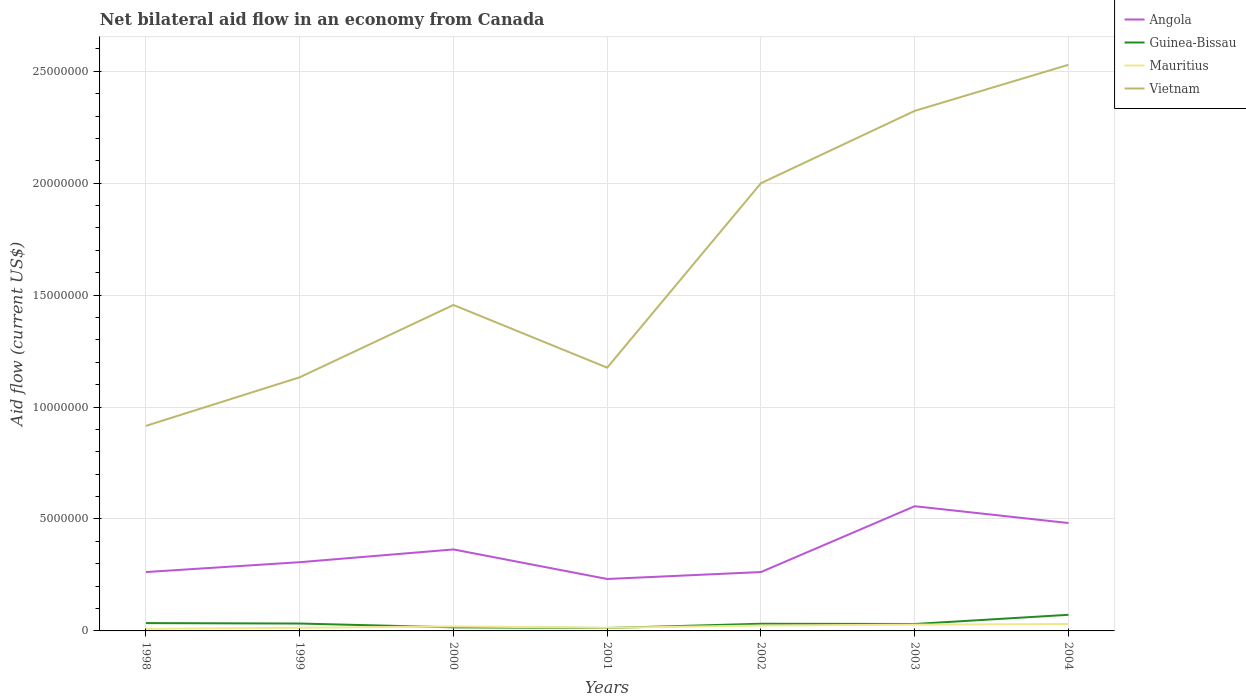Across all years, what is the maximum net bilateral aid flow in Angola?
Offer a terse response. 2.32e+06. In which year was the net bilateral aid flow in Vietnam maximum?
Offer a terse response. 1998. What is the total net bilateral aid flow in Mauritius in the graph?
Your response must be concise. 6.00e+04. What is the difference between the highest and the second highest net bilateral aid flow in Vietnam?
Offer a very short reply. 1.61e+07. Is the net bilateral aid flow in Mauritius strictly greater than the net bilateral aid flow in Vietnam over the years?
Keep it short and to the point. Yes. What is the difference between two consecutive major ticks on the Y-axis?
Your answer should be compact. 5.00e+06. Does the graph contain any zero values?
Keep it short and to the point. No. Where does the legend appear in the graph?
Keep it short and to the point. Top right. What is the title of the graph?
Offer a terse response. Net bilateral aid flow in an economy from Canada. Does "Latin America(developing only)" appear as one of the legend labels in the graph?
Provide a short and direct response. No. What is the label or title of the X-axis?
Offer a terse response. Years. What is the Aid flow (current US$) in Angola in 1998?
Provide a succinct answer. 2.63e+06. What is the Aid flow (current US$) of Guinea-Bissau in 1998?
Give a very brief answer. 3.50e+05. What is the Aid flow (current US$) of Vietnam in 1998?
Provide a succinct answer. 9.16e+06. What is the Aid flow (current US$) of Angola in 1999?
Offer a very short reply. 3.07e+06. What is the Aid flow (current US$) of Mauritius in 1999?
Ensure brevity in your answer.  1.40e+05. What is the Aid flow (current US$) in Vietnam in 1999?
Your answer should be compact. 1.13e+07. What is the Aid flow (current US$) in Angola in 2000?
Provide a succinct answer. 3.64e+06. What is the Aid flow (current US$) of Guinea-Bissau in 2000?
Give a very brief answer. 1.60e+05. What is the Aid flow (current US$) of Vietnam in 2000?
Offer a very short reply. 1.46e+07. What is the Aid flow (current US$) of Angola in 2001?
Give a very brief answer. 2.32e+06. What is the Aid flow (current US$) in Mauritius in 2001?
Your response must be concise. 1.40e+05. What is the Aid flow (current US$) of Vietnam in 2001?
Offer a very short reply. 1.18e+07. What is the Aid flow (current US$) of Angola in 2002?
Provide a succinct answer. 2.63e+06. What is the Aid flow (current US$) in Guinea-Bissau in 2002?
Your answer should be compact. 3.20e+05. What is the Aid flow (current US$) in Mauritius in 2002?
Your answer should be compact. 2.40e+05. What is the Aid flow (current US$) of Vietnam in 2002?
Keep it short and to the point. 2.00e+07. What is the Aid flow (current US$) in Angola in 2003?
Offer a terse response. 5.57e+06. What is the Aid flow (current US$) in Guinea-Bissau in 2003?
Make the answer very short. 3.10e+05. What is the Aid flow (current US$) in Mauritius in 2003?
Provide a succinct answer. 2.80e+05. What is the Aid flow (current US$) in Vietnam in 2003?
Provide a succinct answer. 2.32e+07. What is the Aid flow (current US$) in Angola in 2004?
Your answer should be compact. 4.82e+06. What is the Aid flow (current US$) of Guinea-Bissau in 2004?
Give a very brief answer. 7.20e+05. What is the Aid flow (current US$) in Vietnam in 2004?
Make the answer very short. 2.53e+07. Across all years, what is the maximum Aid flow (current US$) in Angola?
Ensure brevity in your answer.  5.57e+06. Across all years, what is the maximum Aid flow (current US$) in Guinea-Bissau?
Your response must be concise. 7.20e+05. Across all years, what is the maximum Aid flow (current US$) in Mauritius?
Offer a very short reply. 3.10e+05. Across all years, what is the maximum Aid flow (current US$) in Vietnam?
Your answer should be very brief. 2.53e+07. Across all years, what is the minimum Aid flow (current US$) of Angola?
Make the answer very short. 2.32e+06. Across all years, what is the minimum Aid flow (current US$) in Vietnam?
Make the answer very short. 9.16e+06. What is the total Aid flow (current US$) of Angola in the graph?
Ensure brevity in your answer.  2.47e+07. What is the total Aid flow (current US$) in Guinea-Bissau in the graph?
Provide a short and direct response. 2.32e+06. What is the total Aid flow (current US$) in Mauritius in the graph?
Give a very brief answer. 1.40e+06. What is the total Aid flow (current US$) in Vietnam in the graph?
Make the answer very short. 1.15e+08. What is the difference between the Aid flow (current US$) of Angola in 1998 and that in 1999?
Make the answer very short. -4.40e+05. What is the difference between the Aid flow (current US$) of Guinea-Bissau in 1998 and that in 1999?
Provide a short and direct response. 2.00e+04. What is the difference between the Aid flow (current US$) in Vietnam in 1998 and that in 1999?
Offer a very short reply. -2.17e+06. What is the difference between the Aid flow (current US$) in Angola in 1998 and that in 2000?
Give a very brief answer. -1.01e+06. What is the difference between the Aid flow (current US$) of Mauritius in 1998 and that in 2000?
Offer a very short reply. -1.10e+05. What is the difference between the Aid flow (current US$) in Vietnam in 1998 and that in 2000?
Offer a terse response. -5.40e+06. What is the difference between the Aid flow (current US$) of Guinea-Bissau in 1998 and that in 2001?
Keep it short and to the point. 2.20e+05. What is the difference between the Aid flow (current US$) in Mauritius in 1998 and that in 2001?
Give a very brief answer. -5.00e+04. What is the difference between the Aid flow (current US$) of Vietnam in 1998 and that in 2001?
Give a very brief answer. -2.60e+06. What is the difference between the Aid flow (current US$) of Guinea-Bissau in 1998 and that in 2002?
Your answer should be compact. 3.00e+04. What is the difference between the Aid flow (current US$) of Mauritius in 1998 and that in 2002?
Provide a succinct answer. -1.50e+05. What is the difference between the Aid flow (current US$) of Vietnam in 1998 and that in 2002?
Provide a succinct answer. -1.08e+07. What is the difference between the Aid flow (current US$) of Angola in 1998 and that in 2003?
Your answer should be compact. -2.94e+06. What is the difference between the Aid flow (current US$) in Mauritius in 1998 and that in 2003?
Give a very brief answer. -1.90e+05. What is the difference between the Aid flow (current US$) in Vietnam in 1998 and that in 2003?
Give a very brief answer. -1.41e+07. What is the difference between the Aid flow (current US$) of Angola in 1998 and that in 2004?
Give a very brief answer. -2.19e+06. What is the difference between the Aid flow (current US$) of Guinea-Bissau in 1998 and that in 2004?
Make the answer very short. -3.70e+05. What is the difference between the Aid flow (current US$) in Mauritius in 1998 and that in 2004?
Your response must be concise. -2.20e+05. What is the difference between the Aid flow (current US$) in Vietnam in 1998 and that in 2004?
Provide a short and direct response. -1.61e+07. What is the difference between the Aid flow (current US$) in Angola in 1999 and that in 2000?
Keep it short and to the point. -5.70e+05. What is the difference between the Aid flow (current US$) in Vietnam in 1999 and that in 2000?
Provide a short and direct response. -3.23e+06. What is the difference between the Aid flow (current US$) in Angola in 1999 and that in 2001?
Make the answer very short. 7.50e+05. What is the difference between the Aid flow (current US$) in Guinea-Bissau in 1999 and that in 2001?
Provide a succinct answer. 2.00e+05. What is the difference between the Aid flow (current US$) of Vietnam in 1999 and that in 2001?
Ensure brevity in your answer.  -4.30e+05. What is the difference between the Aid flow (current US$) in Guinea-Bissau in 1999 and that in 2002?
Make the answer very short. 10000. What is the difference between the Aid flow (current US$) of Vietnam in 1999 and that in 2002?
Your answer should be compact. -8.67e+06. What is the difference between the Aid flow (current US$) in Angola in 1999 and that in 2003?
Provide a short and direct response. -2.50e+06. What is the difference between the Aid flow (current US$) in Vietnam in 1999 and that in 2003?
Provide a short and direct response. -1.19e+07. What is the difference between the Aid flow (current US$) in Angola in 1999 and that in 2004?
Provide a succinct answer. -1.75e+06. What is the difference between the Aid flow (current US$) of Guinea-Bissau in 1999 and that in 2004?
Provide a short and direct response. -3.90e+05. What is the difference between the Aid flow (current US$) in Vietnam in 1999 and that in 2004?
Offer a terse response. -1.40e+07. What is the difference between the Aid flow (current US$) of Angola in 2000 and that in 2001?
Give a very brief answer. 1.32e+06. What is the difference between the Aid flow (current US$) in Mauritius in 2000 and that in 2001?
Offer a terse response. 6.00e+04. What is the difference between the Aid flow (current US$) of Vietnam in 2000 and that in 2001?
Keep it short and to the point. 2.80e+06. What is the difference between the Aid flow (current US$) in Angola in 2000 and that in 2002?
Make the answer very short. 1.01e+06. What is the difference between the Aid flow (current US$) of Guinea-Bissau in 2000 and that in 2002?
Ensure brevity in your answer.  -1.60e+05. What is the difference between the Aid flow (current US$) in Vietnam in 2000 and that in 2002?
Provide a short and direct response. -5.44e+06. What is the difference between the Aid flow (current US$) in Angola in 2000 and that in 2003?
Offer a very short reply. -1.93e+06. What is the difference between the Aid flow (current US$) in Guinea-Bissau in 2000 and that in 2003?
Your response must be concise. -1.50e+05. What is the difference between the Aid flow (current US$) in Mauritius in 2000 and that in 2003?
Offer a terse response. -8.00e+04. What is the difference between the Aid flow (current US$) of Vietnam in 2000 and that in 2003?
Ensure brevity in your answer.  -8.67e+06. What is the difference between the Aid flow (current US$) of Angola in 2000 and that in 2004?
Make the answer very short. -1.18e+06. What is the difference between the Aid flow (current US$) of Guinea-Bissau in 2000 and that in 2004?
Ensure brevity in your answer.  -5.60e+05. What is the difference between the Aid flow (current US$) of Mauritius in 2000 and that in 2004?
Offer a terse response. -1.10e+05. What is the difference between the Aid flow (current US$) of Vietnam in 2000 and that in 2004?
Your answer should be very brief. -1.07e+07. What is the difference between the Aid flow (current US$) in Angola in 2001 and that in 2002?
Provide a short and direct response. -3.10e+05. What is the difference between the Aid flow (current US$) of Guinea-Bissau in 2001 and that in 2002?
Provide a succinct answer. -1.90e+05. What is the difference between the Aid flow (current US$) in Vietnam in 2001 and that in 2002?
Ensure brevity in your answer.  -8.24e+06. What is the difference between the Aid flow (current US$) of Angola in 2001 and that in 2003?
Ensure brevity in your answer.  -3.25e+06. What is the difference between the Aid flow (current US$) of Vietnam in 2001 and that in 2003?
Give a very brief answer. -1.15e+07. What is the difference between the Aid flow (current US$) in Angola in 2001 and that in 2004?
Keep it short and to the point. -2.50e+06. What is the difference between the Aid flow (current US$) in Guinea-Bissau in 2001 and that in 2004?
Offer a terse response. -5.90e+05. What is the difference between the Aid flow (current US$) in Mauritius in 2001 and that in 2004?
Offer a terse response. -1.70e+05. What is the difference between the Aid flow (current US$) of Vietnam in 2001 and that in 2004?
Give a very brief answer. -1.35e+07. What is the difference between the Aid flow (current US$) in Angola in 2002 and that in 2003?
Provide a short and direct response. -2.94e+06. What is the difference between the Aid flow (current US$) in Vietnam in 2002 and that in 2003?
Your response must be concise. -3.23e+06. What is the difference between the Aid flow (current US$) in Angola in 2002 and that in 2004?
Make the answer very short. -2.19e+06. What is the difference between the Aid flow (current US$) of Guinea-Bissau in 2002 and that in 2004?
Provide a succinct answer. -4.00e+05. What is the difference between the Aid flow (current US$) of Mauritius in 2002 and that in 2004?
Offer a terse response. -7.00e+04. What is the difference between the Aid flow (current US$) in Vietnam in 2002 and that in 2004?
Provide a succinct answer. -5.29e+06. What is the difference between the Aid flow (current US$) of Angola in 2003 and that in 2004?
Offer a very short reply. 7.50e+05. What is the difference between the Aid flow (current US$) in Guinea-Bissau in 2003 and that in 2004?
Ensure brevity in your answer.  -4.10e+05. What is the difference between the Aid flow (current US$) of Mauritius in 2003 and that in 2004?
Make the answer very short. -3.00e+04. What is the difference between the Aid flow (current US$) in Vietnam in 2003 and that in 2004?
Your answer should be compact. -2.06e+06. What is the difference between the Aid flow (current US$) of Angola in 1998 and the Aid flow (current US$) of Guinea-Bissau in 1999?
Offer a terse response. 2.30e+06. What is the difference between the Aid flow (current US$) in Angola in 1998 and the Aid flow (current US$) in Mauritius in 1999?
Offer a very short reply. 2.49e+06. What is the difference between the Aid flow (current US$) of Angola in 1998 and the Aid flow (current US$) of Vietnam in 1999?
Your answer should be compact. -8.70e+06. What is the difference between the Aid flow (current US$) of Guinea-Bissau in 1998 and the Aid flow (current US$) of Vietnam in 1999?
Make the answer very short. -1.10e+07. What is the difference between the Aid flow (current US$) of Mauritius in 1998 and the Aid flow (current US$) of Vietnam in 1999?
Offer a very short reply. -1.12e+07. What is the difference between the Aid flow (current US$) in Angola in 1998 and the Aid flow (current US$) in Guinea-Bissau in 2000?
Offer a terse response. 2.47e+06. What is the difference between the Aid flow (current US$) in Angola in 1998 and the Aid flow (current US$) in Mauritius in 2000?
Your response must be concise. 2.43e+06. What is the difference between the Aid flow (current US$) of Angola in 1998 and the Aid flow (current US$) of Vietnam in 2000?
Offer a terse response. -1.19e+07. What is the difference between the Aid flow (current US$) of Guinea-Bissau in 1998 and the Aid flow (current US$) of Mauritius in 2000?
Your answer should be compact. 1.50e+05. What is the difference between the Aid flow (current US$) of Guinea-Bissau in 1998 and the Aid flow (current US$) of Vietnam in 2000?
Provide a short and direct response. -1.42e+07. What is the difference between the Aid flow (current US$) in Mauritius in 1998 and the Aid flow (current US$) in Vietnam in 2000?
Offer a terse response. -1.45e+07. What is the difference between the Aid flow (current US$) of Angola in 1998 and the Aid flow (current US$) of Guinea-Bissau in 2001?
Ensure brevity in your answer.  2.50e+06. What is the difference between the Aid flow (current US$) of Angola in 1998 and the Aid flow (current US$) of Mauritius in 2001?
Ensure brevity in your answer.  2.49e+06. What is the difference between the Aid flow (current US$) in Angola in 1998 and the Aid flow (current US$) in Vietnam in 2001?
Make the answer very short. -9.13e+06. What is the difference between the Aid flow (current US$) in Guinea-Bissau in 1998 and the Aid flow (current US$) in Mauritius in 2001?
Offer a very short reply. 2.10e+05. What is the difference between the Aid flow (current US$) of Guinea-Bissau in 1998 and the Aid flow (current US$) of Vietnam in 2001?
Keep it short and to the point. -1.14e+07. What is the difference between the Aid flow (current US$) of Mauritius in 1998 and the Aid flow (current US$) of Vietnam in 2001?
Your response must be concise. -1.17e+07. What is the difference between the Aid flow (current US$) of Angola in 1998 and the Aid flow (current US$) of Guinea-Bissau in 2002?
Keep it short and to the point. 2.31e+06. What is the difference between the Aid flow (current US$) in Angola in 1998 and the Aid flow (current US$) in Mauritius in 2002?
Offer a very short reply. 2.39e+06. What is the difference between the Aid flow (current US$) in Angola in 1998 and the Aid flow (current US$) in Vietnam in 2002?
Your answer should be compact. -1.74e+07. What is the difference between the Aid flow (current US$) in Guinea-Bissau in 1998 and the Aid flow (current US$) in Vietnam in 2002?
Your response must be concise. -1.96e+07. What is the difference between the Aid flow (current US$) in Mauritius in 1998 and the Aid flow (current US$) in Vietnam in 2002?
Make the answer very short. -1.99e+07. What is the difference between the Aid flow (current US$) of Angola in 1998 and the Aid flow (current US$) of Guinea-Bissau in 2003?
Offer a terse response. 2.32e+06. What is the difference between the Aid flow (current US$) of Angola in 1998 and the Aid flow (current US$) of Mauritius in 2003?
Ensure brevity in your answer.  2.35e+06. What is the difference between the Aid flow (current US$) in Angola in 1998 and the Aid flow (current US$) in Vietnam in 2003?
Your response must be concise. -2.06e+07. What is the difference between the Aid flow (current US$) in Guinea-Bissau in 1998 and the Aid flow (current US$) in Mauritius in 2003?
Your answer should be compact. 7.00e+04. What is the difference between the Aid flow (current US$) of Guinea-Bissau in 1998 and the Aid flow (current US$) of Vietnam in 2003?
Your answer should be compact. -2.29e+07. What is the difference between the Aid flow (current US$) of Mauritius in 1998 and the Aid flow (current US$) of Vietnam in 2003?
Your answer should be compact. -2.31e+07. What is the difference between the Aid flow (current US$) in Angola in 1998 and the Aid flow (current US$) in Guinea-Bissau in 2004?
Your response must be concise. 1.91e+06. What is the difference between the Aid flow (current US$) of Angola in 1998 and the Aid flow (current US$) of Mauritius in 2004?
Your answer should be compact. 2.32e+06. What is the difference between the Aid flow (current US$) in Angola in 1998 and the Aid flow (current US$) in Vietnam in 2004?
Provide a succinct answer. -2.27e+07. What is the difference between the Aid flow (current US$) of Guinea-Bissau in 1998 and the Aid flow (current US$) of Mauritius in 2004?
Offer a terse response. 4.00e+04. What is the difference between the Aid flow (current US$) in Guinea-Bissau in 1998 and the Aid flow (current US$) in Vietnam in 2004?
Your answer should be compact. -2.49e+07. What is the difference between the Aid flow (current US$) in Mauritius in 1998 and the Aid flow (current US$) in Vietnam in 2004?
Give a very brief answer. -2.52e+07. What is the difference between the Aid flow (current US$) of Angola in 1999 and the Aid flow (current US$) of Guinea-Bissau in 2000?
Make the answer very short. 2.91e+06. What is the difference between the Aid flow (current US$) of Angola in 1999 and the Aid flow (current US$) of Mauritius in 2000?
Your response must be concise. 2.87e+06. What is the difference between the Aid flow (current US$) of Angola in 1999 and the Aid flow (current US$) of Vietnam in 2000?
Provide a succinct answer. -1.15e+07. What is the difference between the Aid flow (current US$) of Guinea-Bissau in 1999 and the Aid flow (current US$) of Mauritius in 2000?
Provide a succinct answer. 1.30e+05. What is the difference between the Aid flow (current US$) of Guinea-Bissau in 1999 and the Aid flow (current US$) of Vietnam in 2000?
Your answer should be very brief. -1.42e+07. What is the difference between the Aid flow (current US$) of Mauritius in 1999 and the Aid flow (current US$) of Vietnam in 2000?
Make the answer very short. -1.44e+07. What is the difference between the Aid flow (current US$) of Angola in 1999 and the Aid flow (current US$) of Guinea-Bissau in 2001?
Provide a short and direct response. 2.94e+06. What is the difference between the Aid flow (current US$) of Angola in 1999 and the Aid flow (current US$) of Mauritius in 2001?
Offer a terse response. 2.93e+06. What is the difference between the Aid flow (current US$) in Angola in 1999 and the Aid flow (current US$) in Vietnam in 2001?
Your answer should be very brief. -8.69e+06. What is the difference between the Aid flow (current US$) in Guinea-Bissau in 1999 and the Aid flow (current US$) in Vietnam in 2001?
Give a very brief answer. -1.14e+07. What is the difference between the Aid flow (current US$) of Mauritius in 1999 and the Aid flow (current US$) of Vietnam in 2001?
Provide a succinct answer. -1.16e+07. What is the difference between the Aid flow (current US$) in Angola in 1999 and the Aid flow (current US$) in Guinea-Bissau in 2002?
Your answer should be very brief. 2.75e+06. What is the difference between the Aid flow (current US$) of Angola in 1999 and the Aid flow (current US$) of Mauritius in 2002?
Provide a succinct answer. 2.83e+06. What is the difference between the Aid flow (current US$) of Angola in 1999 and the Aid flow (current US$) of Vietnam in 2002?
Your response must be concise. -1.69e+07. What is the difference between the Aid flow (current US$) in Guinea-Bissau in 1999 and the Aid flow (current US$) in Mauritius in 2002?
Your answer should be compact. 9.00e+04. What is the difference between the Aid flow (current US$) in Guinea-Bissau in 1999 and the Aid flow (current US$) in Vietnam in 2002?
Provide a short and direct response. -1.97e+07. What is the difference between the Aid flow (current US$) of Mauritius in 1999 and the Aid flow (current US$) of Vietnam in 2002?
Your answer should be very brief. -1.99e+07. What is the difference between the Aid flow (current US$) of Angola in 1999 and the Aid flow (current US$) of Guinea-Bissau in 2003?
Make the answer very short. 2.76e+06. What is the difference between the Aid flow (current US$) of Angola in 1999 and the Aid flow (current US$) of Mauritius in 2003?
Offer a very short reply. 2.79e+06. What is the difference between the Aid flow (current US$) of Angola in 1999 and the Aid flow (current US$) of Vietnam in 2003?
Your answer should be compact. -2.02e+07. What is the difference between the Aid flow (current US$) in Guinea-Bissau in 1999 and the Aid flow (current US$) in Mauritius in 2003?
Ensure brevity in your answer.  5.00e+04. What is the difference between the Aid flow (current US$) in Guinea-Bissau in 1999 and the Aid flow (current US$) in Vietnam in 2003?
Your answer should be very brief. -2.29e+07. What is the difference between the Aid flow (current US$) of Mauritius in 1999 and the Aid flow (current US$) of Vietnam in 2003?
Provide a short and direct response. -2.31e+07. What is the difference between the Aid flow (current US$) in Angola in 1999 and the Aid flow (current US$) in Guinea-Bissau in 2004?
Offer a very short reply. 2.35e+06. What is the difference between the Aid flow (current US$) in Angola in 1999 and the Aid flow (current US$) in Mauritius in 2004?
Offer a terse response. 2.76e+06. What is the difference between the Aid flow (current US$) of Angola in 1999 and the Aid flow (current US$) of Vietnam in 2004?
Your answer should be compact. -2.22e+07. What is the difference between the Aid flow (current US$) of Guinea-Bissau in 1999 and the Aid flow (current US$) of Vietnam in 2004?
Make the answer very short. -2.50e+07. What is the difference between the Aid flow (current US$) of Mauritius in 1999 and the Aid flow (current US$) of Vietnam in 2004?
Your answer should be very brief. -2.52e+07. What is the difference between the Aid flow (current US$) in Angola in 2000 and the Aid flow (current US$) in Guinea-Bissau in 2001?
Your response must be concise. 3.51e+06. What is the difference between the Aid flow (current US$) in Angola in 2000 and the Aid flow (current US$) in Mauritius in 2001?
Offer a very short reply. 3.50e+06. What is the difference between the Aid flow (current US$) of Angola in 2000 and the Aid flow (current US$) of Vietnam in 2001?
Offer a terse response. -8.12e+06. What is the difference between the Aid flow (current US$) of Guinea-Bissau in 2000 and the Aid flow (current US$) of Vietnam in 2001?
Your response must be concise. -1.16e+07. What is the difference between the Aid flow (current US$) in Mauritius in 2000 and the Aid flow (current US$) in Vietnam in 2001?
Your answer should be very brief. -1.16e+07. What is the difference between the Aid flow (current US$) in Angola in 2000 and the Aid flow (current US$) in Guinea-Bissau in 2002?
Provide a short and direct response. 3.32e+06. What is the difference between the Aid flow (current US$) in Angola in 2000 and the Aid flow (current US$) in Mauritius in 2002?
Your answer should be compact. 3.40e+06. What is the difference between the Aid flow (current US$) of Angola in 2000 and the Aid flow (current US$) of Vietnam in 2002?
Provide a succinct answer. -1.64e+07. What is the difference between the Aid flow (current US$) of Guinea-Bissau in 2000 and the Aid flow (current US$) of Mauritius in 2002?
Your answer should be very brief. -8.00e+04. What is the difference between the Aid flow (current US$) in Guinea-Bissau in 2000 and the Aid flow (current US$) in Vietnam in 2002?
Offer a very short reply. -1.98e+07. What is the difference between the Aid flow (current US$) of Mauritius in 2000 and the Aid flow (current US$) of Vietnam in 2002?
Your answer should be compact. -1.98e+07. What is the difference between the Aid flow (current US$) of Angola in 2000 and the Aid flow (current US$) of Guinea-Bissau in 2003?
Offer a terse response. 3.33e+06. What is the difference between the Aid flow (current US$) of Angola in 2000 and the Aid flow (current US$) of Mauritius in 2003?
Keep it short and to the point. 3.36e+06. What is the difference between the Aid flow (current US$) in Angola in 2000 and the Aid flow (current US$) in Vietnam in 2003?
Give a very brief answer. -1.96e+07. What is the difference between the Aid flow (current US$) in Guinea-Bissau in 2000 and the Aid flow (current US$) in Vietnam in 2003?
Offer a very short reply. -2.31e+07. What is the difference between the Aid flow (current US$) of Mauritius in 2000 and the Aid flow (current US$) of Vietnam in 2003?
Your response must be concise. -2.30e+07. What is the difference between the Aid flow (current US$) of Angola in 2000 and the Aid flow (current US$) of Guinea-Bissau in 2004?
Provide a short and direct response. 2.92e+06. What is the difference between the Aid flow (current US$) of Angola in 2000 and the Aid flow (current US$) of Mauritius in 2004?
Give a very brief answer. 3.33e+06. What is the difference between the Aid flow (current US$) in Angola in 2000 and the Aid flow (current US$) in Vietnam in 2004?
Give a very brief answer. -2.16e+07. What is the difference between the Aid flow (current US$) in Guinea-Bissau in 2000 and the Aid flow (current US$) in Vietnam in 2004?
Provide a short and direct response. -2.51e+07. What is the difference between the Aid flow (current US$) of Mauritius in 2000 and the Aid flow (current US$) of Vietnam in 2004?
Keep it short and to the point. -2.51e+07. What is the difference between the Aid flow (current US$) in Angola in 2001 and the Aid flow (current US$) in Mauritius in 2002?
Ensure brevity in your answer.  2.08e+06. What is the difference between the Aid flow (current US$) in Angola in 2001 and the Aid flow (current US$) in Vietnam in 2002?
Give a very brief answer. -1.77e+07. What is the difference between the Aid flow (current US$) in Guinea-Bissau in 2001 and the Aid flow (current US$) in Mauritius in 2002?
Your response must be concise. -1.10e+05. What is the difference between the Aid flow (current US$) in Guinea-Bissau in 2001 and the Aid flow (current US$) in Vietnam in 2002?
Your answer should be very brief. -1.99e+07. What is the difference between the Aid flow (current US$) in Mauritius in 2001 and the Aid flow (current US$) in Vietnam in 2002?
Provide a succinct answer. -1.99e+07. What is the difference between the Aid flow (current US$) in Angola in 2001 and the Aid flow (current US$) in Guinea-Bissau in 2003?
Your response must be concise. 2.01e+06. What is the difference between the Aid flow (current US$) of Angola in 2001 and the Aid flow (current US$) of Mauritius in 2003?
Your answer should be very brief. 2.04e+06. What is the difference between the Aid flow (current US$) in Angola in 2001 and the Aid flow (current US$) in Vietnam in 2003?
Offer a terse response. -2.09e+07. What is the difference between the Aid flow (current US$) in Guinea-Bissau in 2001 and the Aid flow (current US$) in Vietnam in 2003?
Offer a very short reply. -2.31e+07. What is the difference between the Aid flow (current US$) of Mauritius in 2001 and the Aid flow (current US$) of Vietnam in 2003?
Provide a short and direct response. -2.31e+07. What is the difference between the Aid flow (current US$) in Angola in 2001 and the Aid flow (current US$) in Guinea-Bissau in 2004?
Offer a very short reply. 1.60e+06. What is the difference between the Aid flow (current US$) of Angola in 2001 and the Aid flow (current US$) of Mauritius in 2004?
Offer a terse response. 2.01e+06. What is the difference between the Aid flow (current US$) in Angola in 2001 and the Aid flow (current US$) in Vietnam in 2004?
Your answer should be compact. -2.30e+07. What is the difference between the Aid flow (current US$) of Guinea-Bissau in 2001 and the Aid flow (current US$) of Vietnam in 2004?
Your answer should be very brief. -2.52e+07. What is the difference between the Aid flow (current US$) in Mauritius in 2001 and the Aid flow (current US$) in Vietnam in 2004?
Provide a succinct answer. -2.52e+07. What is the difference between the Aid flow (current US$) in Angola in 2002 and the Aid flow (current US$) in Guinea-Bissau in 2003?
Give a very brief answer. 2.32e+06. What is the difference between the Aid flow (current US$) of Angola in 2002 and the Aid flow (current US$) of Mauritius in 2003?
Offer a terse response. 2.35e+06. What is the difference between the Aid flow (current US$) in Angola in 2002 and the Aid flow (current US$) in Vietnam in 2003?
Provide a short and direct response. -2.06e+07. What is the difference between the Aid flow (current US$) in Guinea-Bissau in 2002 and the Aid flow (current US$) in Vietnam in 2003?
Your response must be concise. -2.29e+07. What is the difference between the Aid flow (current US$) in Mauritius in 2002 and the Aid flow (current US$) in Vietnam in 2003?
Give a very brief answer. -2.30e+07. What is the difference between the Aid flow (current US$) in Angola in 2002 and the Aid flow (current US$) in Guinea-Bissau in 2004?
Your answer should be compact. 1.91e+06. What is the difference between the Aid flow (current US$) in Angola in 2002 and the Aid flow (current US$) in Mauritius in 2004?
Your answer should be compact. 2.32e+06. What is the difference between the Aid flow (current US$) of Angola in 2002 and the Aid flow (current US$) of Vietnam in 2004?
Provide a short and direct response. -2.27e+07. What is the difference between the Aid flow (current US$) in Guinea-Bissau in 2002 and the Aid flow (current US$) in Vietnam in 2004?
Make the answer very short. -2.50e+07. What is the difference between the Aid flow (current US$) of Mauritius in 2002 and the Aid flow (current US$) of Vietnam in 2004?
Offer a terse response. -2.50e+07. What is the difference between the Aid flow (current US$) of Angola in 2003 and the Aid flow (current US$) of Guinea-Bissau in 2004?
Offer a very short reply. 4.85e+06. What is the difference between the Aid flow (current US$) of Angola in 2003 and the Aid flow (current US$) of Mauritius in 2004?
Ensure brevity in your answer.  5.26e+06. What is the difference between the Aid flow (current US$) of Angola in 2003 and the Aid flow (current US$) of Vietnam in 2004?
Provide a succinct answer. -1.97e+07. What is the difference between the Aid flow (current US$) in Guinea-Bissau in 2003 and the Aid flow (current US$) in Mauritius in 2004?
Give a very brief answer. 0. What is the difference between the Aid flow (current US$) of Guinea-Bissau in 2003 and the Aid flow (current US$) of Vietnam in 2004?
Keep it short and to the point. -2.50e+07. What is the difference between the Aid flow (current US$) of Mauritius in 2003 and the Aid flow (current US$) of Vietnam in 2004?
Your answer should be very brief. -2.50e+07. What is the average Aid flow (current US$) of Angola per year?
Make the answer very short. 3.53e+06. What is the average Aid flow (current US$) of Guinea-Bissau per year?
Give a very brief answer. 3.31e+05. What is the average Aid flow (current US$) in Mauritius per year?
Your answer should be very brief. 2.00e+05. What is the average Aid flow (current US$) of Vietnam per year?
Your response must be concise. 1.65e+07. In the year 1998, what is the difference between the Aid flow (current US$) of Angola and Aid flow (current US$) of Guinea-Bissau?
Ensure brevity in your answer.  2.28e+06. In the year 1998, what is the difference between the Aid flow (current US$) of Angola and Aid flow (current US$) of Mauritius?
Give a very brief answer. 2.54e+06. In the year 1998, what is the difference between the Aid flow (current US$) in Angola and Aid flow (current US$) in Vietnam?
Your answer should be very brief. -6.53e+06. In the year 1998, what is the difference between the Aid flow (current US$) of Guinea-Bissau and Aid flow (current US$) of Vietnam?
Your response must be concise. -8.81e+06. In the year 1998, what is the difference between the Aid flow (current US$) in Mauritius and Aid flow (current US$) in Vietnam?
Your response must be concise. -9.07e+06. In the year 1999, what is the difference between the Aid flow (current US$) of Angola and Aid flow (current US$) of Guinea-Bissau?
Give a very brief answer. 2.74e+06. In the year 1999, what is the difference between the Aid flow (current US$) in Angola and Aid flow (current US$) in Mauritius?
Your answer should be compact. 2.93e+06. In the year 1999, what is the difference between the Aid flow (current US$) in Angola and Aid flow (current US$) in Vietnam?
Ensure brevity in your answer.  -8.26e+06. In the year 1999, what is the difference between the Aid flow (current US$) of Guinea-Bissau and Aid flow (current US$) of Mauritius?
Your answer should be compact. 1.90e+05. In the year 1999, what is the difference between the Aid flow (current US$) of Guinea-Bissau and Aid flow (current US$) of Vietnam?
Keep it short and to the point. -1.10e+07. In the year 1999, what is the difference between the Aid flow (current US$) in Mauritius and Aid flow (current US$) in Vietnam?
Your answer should be very brief. -1.12e+07. In the year 2000, what is the difference between the Aid flow (current US$) in Angola and Aid flow (current US$) in Guinea-Bissau?
Your response must be concise. 3.48e+06. In the year 2000, what is the difference between the Aid flow (current US$) in Angola and Aid flow (current US$) in Mauritius?
Ensure brevity in your answer.  3.44e+06. In the year 2000, what is the difference between the Aid flow (current US$) in Angola and Aid flow (current US$) in Vietnam?
Your answer should be compact. -1.09e+07. In the year 2000, what is the difference between the Aid flow (current US$) in Guinea-Bissau and Aid flow (current US$) in Mauritius?
Provide a succinct answer. -4.00e+04. In the year 2000, what is the difference between the Aid flow (current US$) in Guinea-Bissau and Aid flow (current US$) in Vietnam?
Provide a short and direct response. -1.44e+07. In the year 2000, what is the difference between the Aid flow (current US$) of Mauritius and Aid flow (current US$) of Vietnam?
Offer a terse response. -1.44e+07. In the year 2001, what is the difference between the Aid flow (current US$) in Angola and Aid flow (current US$) in Guinea-Bissau?
Offer a very short reply. 2.19e+06. In the year 2001, what is the difference between the Aid flow (current US$) of Angola and Aid flow (current US$) of Mauritius?
Ensure brevity in your answer.  2.18e+06. In the year 2001, what is the difference between the Aid flow (current US$) in Angola and Aid flow (current US$) in Vietnam?
Offer a very short reply. -9.44e+06. In the year 2001, what is the difference between the Aid flow (current US$) of Guinea-Bissau and Aid flow (current US$) of Mauritius?
Give a very brief answer. -10000. In the year 2001, what is the difference between the Aid flow (current US$) in Guinea-Bissau and Aid flow (current US$) in Vietnam?
Your answer should be very brief. -1.16e+07. In the year 2001, what is the difference between the Aid flow (current US$) in Mauritius and Aid flow (current US$) in Vietnam?
Your answer should be compact. -1.16e+07. In the year 2002, what is the difference between the Aid flow (current US$) in Angola and Aid flow (current US$) in Guinea-Bissau?
Give a very brief answer. 2.31e+06. In the year 2002, what is the difference between the Aid flow (current US$) of Angola and Aid flow (current US$) of Mauritius?
Keep it short and to the point. 2.39e+06. In the year 2002, what is the difference between the Aid flow (current US$) in Angola and Aid flow (current US$) in Vietnam?
Provide a short and direct response. -1.74e+07. In the year 2002, what is the difference between the Aid flow (current US$) of Guinea-Bissau and Aid flow (current US$) of Vietnam?
Keep it short and to the point. -1.97e+07. In the year 2002, what is the difference between the Aid flow (current US$) in Mauritius and Aid flow (current US$) in Vietnam?
Ensure brevity in your answer.  -1.98e+07. In the year 2003, what is the difference between the Aid flow (current US$) of Angola and Aid flow (current US$) of Guinea-Bissau?
Offer a terse response. 5.26e+06. In the year 2003, what is the difference between the Aid flow (current US$) in Angola and Aid flow (current US$) in Mauritius?
Give a very brief answer. 5.29e+06. In the year 2003, what is the difference between the Aid flow (current US$) in Angola and Aid flow (current US$) in Vietnam?
Give a very brief answer. -1.77e+07. In the year 2003, what is the difference between the Aid flow (current US$) of Guinea-Bissau and Aid flow (current US$) of Vietnam?
Provide a succinct answer. -2.29e+07. In the year 2003, what is the difference between the Aid flow (current US$) in Mauritius and Aid flow (current US$) in Vietnam?
Offer a terse response. -2.30e+07. In the year 2004, what is the difference between the Aid flow (current US$) of Angola and Aid flow (current US$) of Guinea-Bissau?
Keep it short and to the point. 4.10e+06. In the year 2004, what is the difference between the Aid flow (current US$) in Angola and Aid flow (current US$) in Mauritius?
Provide a succinct answer. 4.51e+06. In the year 2004, what is the difference between the Aid flow (current US$) of Angola and Aid flow (current US$) of Vietnam?
Give a very brief answer. -2.05e+07. In the year 2004, what is the difference between the Aid flow (current US$) in Guinea-Bissau and Aid flow (current US$) in Vietnam?
Your answer should be compact. -2.46e+07. In the year 2004, what is the difference between the Aid flow (current US$) of Mauritius and Aid flow (current US$) of Vietnam?
Provide a succinct answer. -2.50e+07. What is the ratio of the Aid flow (current US$) of Angola in 1998 to that in 1999?
Provide a short and direct response. 0.86. What is the ratio of the Aid flow (current US$) in Guinea-Bissau in 1998 to that in 1999?
Make the answer very short. 1.06. What is the ratio of the Aid flow (current US$) in Mauritius in 1998 to that in 1999?
Ensure brevity in your answer.  0.64. What is the ratio of the Aid flow (current US$) of Vietnam in 1998 to that in 1999?
Keep it short and to the point. 0.81. What is the ratio of the Aid flow (current US$) of Angola in 1998 to that in 2000?
Your answer should be very brief. 0.72. What is the ratio of the Aid flow (current US$) of Guinea-Bissau in 1998 to that in 2000?
Ensure brevity in your answer.  2.19. What is the ratio of the Aid flow (current US$) in Mauritius in 1998 to that in 2000?
Your answer should be compact. 0.45. What is the ratio of the Aid flow (current US$) of Vietnam in 1998 to that in 2000?
Offer a very short reply. 0.63. What is the ratio of the Aid flow (current US$) in Angola in 1998 to that in 2001?
Your response must be concise. 1.13. What is the ratio of the Aid flow (current US$) in Guinea-Bissau in 1998 to that in 2001?
Keep it short and to the point. 2.69. What is the ratio of the Aid flow (current US$) in Mauritius in 1998 to that in 2001?
Provide a short and direct response. 0.64. What is the ratio of the Aid flow (current US$) in Vietnam in 1998 to that in 2001?
Offer a terse response. 0.78. What is the ratio of the Aid flow (current US$) in Angola in 1998 to that in 2002?
Your answer should be very brief. 1. What is the ratio of the Aid flow (current US$) of Guinea-Bissau in 1998 to that in 2002?
Your answer should be very brief. 1.09. What is the ratio of the Aid flow (current US$) in Vietnam in 1998 to that in 2002?
Ensure brevity in your answer.  0.46. What is the ratio of the Aid flow (current US$) in Angola in 1998 to that in 2003?
Give a very brief answer. 0.47. What is the ratio of the Aid flow (current US$) in Guinea-Bissau in 1998 to that in 2003?
Your answer should be very brief. 1.13. What is the ratio of the Aid flow (current US$) in Mauritius in 1998 to that in 2003?
Give a very brief answer. 0.32. What is the ratio of the Aid flow (current US$) of Vietnam in 1998 to that in 2003?
Ensure brevity in your answer.  0.39. What is the ratio of the Aid flow (current US$) in Angola in 1998 to that in 2004?
Your answer should be compact. 0.55. What is the ratio of the Aid flow (current US$) in Guinea-Bissau in 1998 to that in 2004?
Make the answer very short. 0.49. What is the ratio of the Aid flow (current US$) of Mauritius in 1998 to that in 2004?
Keep it short and to the point. 0.29. What is the ratio of the Aid flow (current US$) in Vietnam in 1998 to that in 2004?
Your answer should be compact. 0.36. What is the ratio of the Aid flow (current US$) of Angola in 1999 to that in 2000?
Ensure brevity in your answer.  0.84. What is the ratio of the Aid flow (current US$) of Guinea-Bissau in 1999 to that in 2000?
Offer a very short reply. 2.06. What is the ratio of the Aid flow (current US$) in Mauritius in 1999 to that in 2000?
Your answer should be compact. 0.7. What is the ratio of the Aid flow (current US$) in Vietnam in 1999 to that in 2000?
Keep it short and to the point. 0.78. What is the ratio of the Aid flow (current US$) in Angola in 1999 to that in 2001?
Provide a short and direct response. 1.32. What is the ratio of the Aid flow (current US$) in Guinea-Bissau in 1999 to that in 2001?
Provide a short and direct response. 2.54. What is the ratio of the Aid flow (current US$) in Mauritius in 1999 to that in 2001?
Give a very brief answer. 1. What is the ratio of the Aid flow (current US$) of Vietnam in 1999 to that in 2001?
Your answer should be very brief. 0.96. What is the ratio of the Aid flow (current US$) of Angola in 1999 to that in 2002?
Keep it short and to the point. 1.17. What is the ratio of the Aid flow (current US$) of Guinea-Bissau in 1999 to that in 2002?
Offer a very short reply. 1.03. What is the ratio of the Aid flow (current US$) of Mauritius in 1999 to that in 2002?
Provide a short and direct response. 0.58. What is the ratio of the Aid flow (current US$) in Vietnam in 1999 to that in 2002?
Give a very brief answer. 0.57. What is the ratio of the Aid flow (current US$) in Angola in 1999 to that in 2003?
Your answer should be compact. 0.55. What is the ratio of the Aid flow (current US$) in Guinea-Bissau in 1999 to that in 2003?
Your answer should be compact. 1.06. What is the ratio of the Aid flow (current US$) of Vietnam in 1999 to that in 2003?
Make the answer very short. 0.49. What is the ratio of the Aid flow (current US$) of Angola in 1999 to that in 2004?
Ensure brevity in your answer.  0.64. What is the ratio of the Aid flow (current US$) of Guinea-Bissau in 1999 to that in 2004?
Your answer should be compact. 0.46. What is the ratio of the Aid flow (current US$) of Mauritius in 1999 to that in 2004?
Provide a succinct answer. 0.45. What is the ratio of the Aid flow (current US$) of Vietnam in 1999 to that in 2004?
Provide a short and direct response. 0.45. What is the ratio of the Aid flow (current US$) of Angola in 2000 to that in 2001?
Provide a succinct answer. 1.57. What is the ratio of the Aid flow (current US$) in Guinea-Bissau in 2000 to that in 2001?
Provide a short and direct response. 1.23. What is the ratio of the Aid flow (current US$) in Mauritius in 2000 to that in 2001?
Provide a succinct answer. 1.43. What is the ratio of the Aid flow (current US$) of Vietnam in 2000 to that in 2001?
Provide a short and direct response. 1.24. What is the ratio of the Aid flow (current US$) of Angola in 2000 to that in 2002?
Offer a very short reply. 1.38. What is the ratio of the Aid flow (current US$) of Mauritius in 2000 to that in 2002?
Ensure brevity in your answer.  0.83. What is the ratio of the Aid flow (current US$) of Vietnam in 2000 to that in 2002?
Your response must be concise. 0.73. What is the ratio of the Aid flow (current US$) in Angola in 2000 to that in 2003?
Provide a succinct answer. 0.65. What is the ratio of the Aid flow (current US$) in Guinea-Bissau in 2000 to that in 2003?
Your answer should be very brief. 0.52. What is the ratio of the Aid flow (current US$) of Mauritius in 2000 to that in 2003?
Provide a succinct answer. 0.71. What is the ratio of the Aid flow (current US$) of Vietnam in 2000 to that in 2003?
Your response must be concise. 0.63. What is the ratio of the Aid flow (current US$) of Angola in 2000 to that in 2004?
Your answer should be compact. 0.76. What is the ratio of the Aid flow (current US$) in Guinea-Bissau in 2000 to that in 2004?
Provide a short and direct response. 0.22. What is the ratio of the Aid flow (current US$) of Mauritius in 2000 to that in 2004?
Make the answer very short. 0.65. What is the ratio of the Aid flow (current US$) of Vietnam in 2000 to that in 2004?
Ensure brevity in your answer.  0.58. What is the ratio of the Aid flow (current US$) in Angola in 2001 to that in 2002?
Your answer should be compact. 0.88. What is the ratio of the Aid flow (current US$) of Guinea-Bissau in 2001 to that in 2002?
Offer a terse response. 0.41. What is the ratio of the Aid flow (current US$) in Mauritius in 2001 to that in 2002?
Your response must be concise. 0.58. What is the ratio of the Aid flow (current US$) of Vietnam in 2001 to that in 2002?
Provide a short and direct response. 0.59. What is the ratio of the Aid flow (current US$) of Angola in 2001 to that in 2003?
Keep it short and to the point. 0.42. What is the ratio of the Aid flow (current US$) in Guinea-Bissau in 2001 to that in 2003?
Ensure brevity in your answer.  0.42. What is the ratio of the Aid flow (current US$) of Vietnam in 2001 to that in 2003?
Provide a short and direct response. 0.51. What is the ratio of the Aid flow (current US$) of Angola in 2001 to that in 2004?
Offer a very short reply. 0.48. What is the ratio of the Aid flow (current US$) of Guinea-Bissau in 2001 to that in 2004?
Provide a succinct answer. 0.18. What is the ratio of the Aid flow (current US$) in Mauritius in 2001 to that in 2004?
Keep it short and to the point. 0.45. What is the ratio of the Aid flow (current US$) of Vietnam in 2001 to that in 2004?
Ensure brevity in your answer.  0.47. What is the ratio of the Aid flow (current US$) in Angola in 2002 to that in 2003?
Offer a terse response. 0.47. What is the ratio of the Aid flow (current US$) in Guinea-Bissau in 2002 to that in 2003?
Provide a succinct answer. 1.03. What is the ratio of the Aid flow (current US$) in Vietnam in 2002 to that in 2003?
Your response must be concise. 0.86. What is the ratio of the Aid flow (current US$) of Angola in 2002 to that in 2004?
Offer a very short reply. 0.55. What is the ratio of the Aid flow (current US$) of Guinea-Bissau in 2002 to that in 2004?
Make the answer very short. 0.44. What is the ratio of the Aid flow (current US$) in Mauritius in 2002 to that in 2004?
Provide a succinct answer. 0.77. What is the ratio of the Aid flow (current US$) of Vietnam in 2002 to that in 2004?
Provide a succinct answer. 0.79. What is the ratio of the Aid flow (current US$) of Angola in 2003 to that in 2004?
Make the answer very short. 1.16. What is the ratio of the Aid flow (current US$) of Guinea-Bissau in 2003 to that in 2004?
Keep it short and to the point. 0.43. What is the ratio of the Aid flow (current US$) of Mauritius in 2003 to that in 2004?
Give a very brief answer. 0.9. What is the ratio of the Aid flow (current US$) in Vietnam in 2003 to that in 2004?
Give a very brief answer. 0.92. What is the difference between the highest and the second highest Aid flow (current US$) in Angola?
Your answer should be very brief. 7.50e+05. What is the difference between the highest and the second highest Aid flow (current US$) in Guinea-Bissau?
Your answer should be compact. 3.70e+05. What is the difference between the highest and the second highest Aid flow (current US$) of Vietnam?
Keep it short and to the point. 2.06e+06. What is the difference between the highest and the lowest Aid flow (current US$) in Angola?
Give a very brief answer. 3.25e+06. What is the difference between the highest and the lowest Aid flow (current US$) of Guinea-Bissau?
Keep it short and to the point. 5.90e+05. What is the difference between the highest and the lowest Aid flow (current US$) of Vietnam?
Offer a terse response. 1.61e+07. 